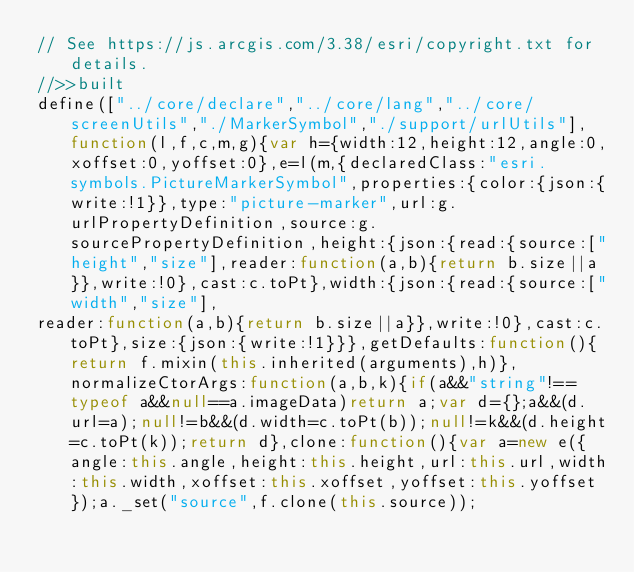Convert code to text. <code><loc_0><loc_0><loc_500><loc_500><_JavaScript_>// See https://js.arcgis.com/3.38/esri/copyright.txt for details.
//>>built
define(["../core/declare","../core/lang","../core/screenUtils","./MarkerSymbol","./support/urlUtils"],function(l,f,c,m,g){var h={width:12,height:12,angle:0,xoffset:0,yoffset:0},e=l(m,{declaredClass:"esri.symbols.PictureMarkerSymbol",properties:{color:{json:{write:!1}},type:"picture-marker",url:g.urlPropertyDefinition,source:g.sourcePropertyDefinition,height:{json:{read:{source:["height","size"],reader:function(a,b){return b.size||a}},write:!0},cast:c.toPt},width:{json:{read:{source:["width","size"],
reader:function(a,b){return b.size||a}},write:!0},cast:c.toPt},size:{json:{write:!1}}},getDefaults:function(){return f.mixin(this.inherited(arguments),h)},normalizeCtorArgs:function(a,b,k){if(a&&"string"!==typeof a&&null==a.imageData)return a;var d={};a&&(d.url=a);null!=b&&(d.width=c.toPt(b));null!=k&&(d.height=c.toPt(k));return d},clone:function(){var a=new e({angle:this.angle,height:this.height,url:this.url,width:this.width,xoffset:this.xoffset,yoffset:this.yoffset});a._set("source",f.clone(this.source));</code> 